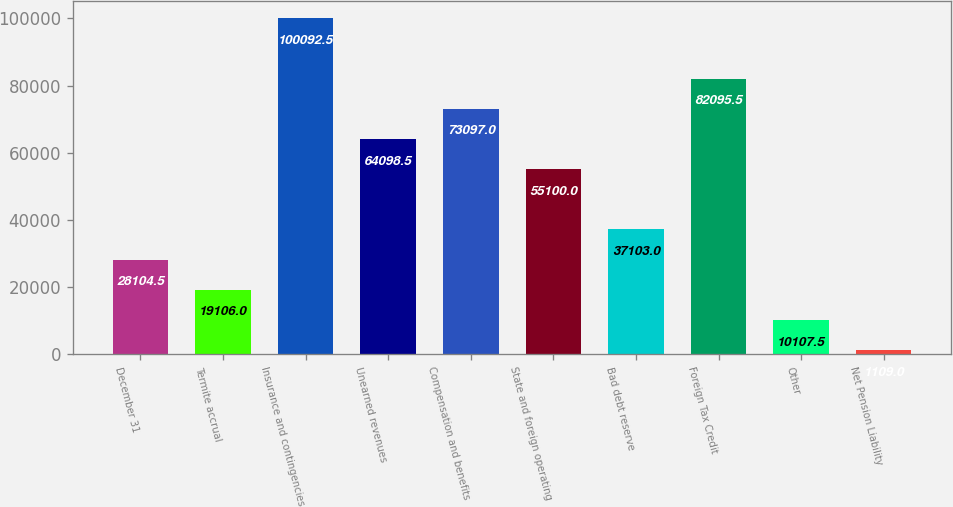Convert chart to OTSL. <chart><loc_0><loc_0><loc_500><loc_500><bar_chart><fcel>December 31<fcel>Termite accrual<fcel>Insurance and contingencies<fcel>Unearned revenues<fcel>Compensation and benefits<fcel>State and foreign operating<fcel>Bad debt reserve<fcel>Foreign Tax Credit<fcel>Other<fcel>Net Pension Liability<nl><fcel>28104.5<fcel>19106<fcel>100092<fcel>64098.5<fcel>73097<fcel>55100<fcel>37103<fcel>82095.5<fcel>10107.5<fcel>1109<nl></chart> 